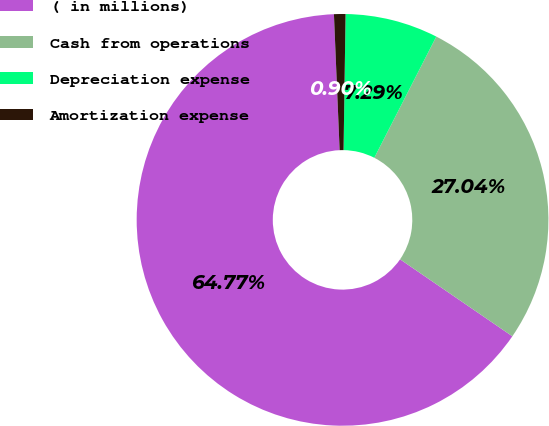Convert chart to OTSL. <chart><loc_0><loc_0><loc_500><loc_500><pie_chart><fcel>( in millions)<fcel>Cash from operations<fcel>Depreciation expense<fcel>Amortization expense<nl><fcel>64.77%<fcel>27.04%<fcel>7.29%<fcel>0.9%<nl></chart> 